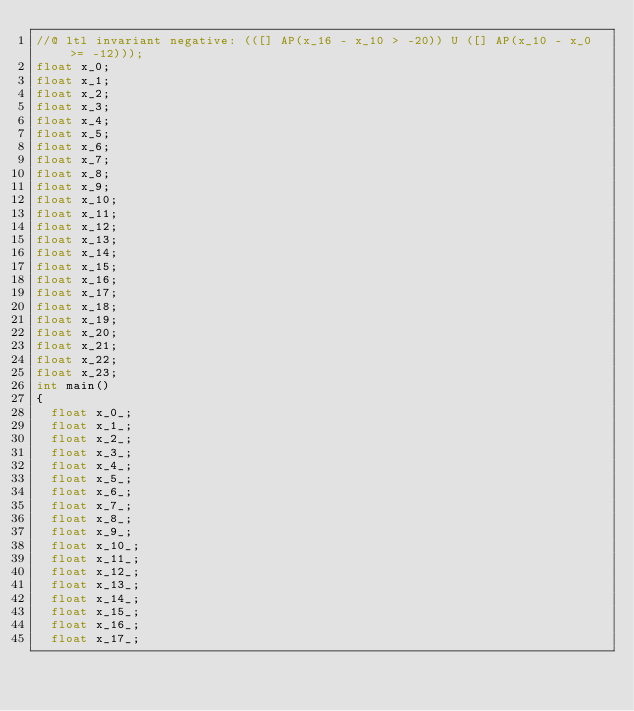Convert code to text. <code><loc_0><loc_0><loc_500><loc_500><_C_>//@ ltl invariant negative: (([] AP(x_16 - x_10 > -20)) U ([] AP(x_10 - x_0 >= -12)));
float x_0;
float x_1;
float x_2;
float x_3;
float x_4;
float x_5;
float x_6;
float x_7;
float x_8;
float x_9;
float x_10;
float x_11;
float x_12;
float x_13;
float x_14;
float x_15;
float x_16;
float x_17;
float x_18;
float x_19;
float x_20;
float x_21;
float x_22;
float x_23;
int main()
{
  float x_0_;
  float x_1_;
  float x_2_;
  float x_3_;
  float x_4_;
  float x_5_;
  float x_6_;
  float x_7_;
  float x_8_;
  float x_9_;
  float x_10_;
  float x_11_;
  float x_12_;
  float x_13_;
  float x_14_;
  float x_15_;
  float x_16_;
  float x_17_;</code> 